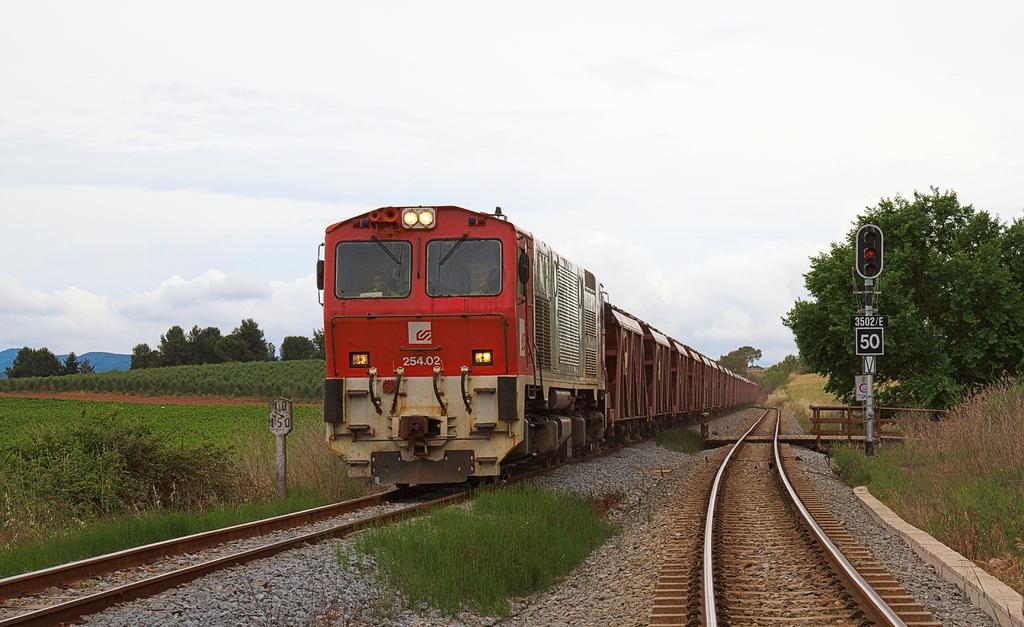What is the number of the train engine?
Provide a succinct answer. 254.02. What is the train number located on front, center of train?
Give a very brief answer. 254.02. 